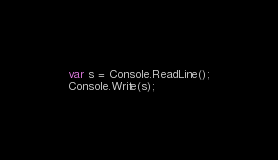<code> <loc_0><loc_0><loc_500><loc_500><_C#_>var s = Console.ReadLine();
Console.Write(s);</code> 